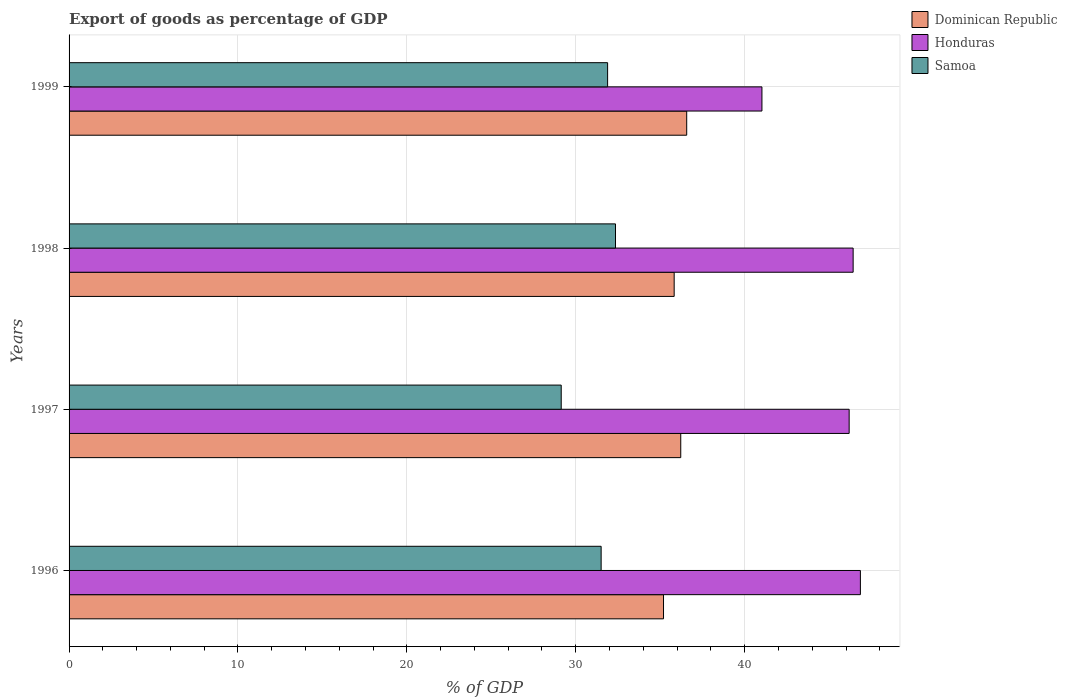How many different coloured bars are there?
Your answer should be compact. 3. How many groups of bars are there?
Offer a very short reply. 4. Are the number of bars on each tick of the Y-axis equal?
Your answer should be compact. Yes. How many bars are there on the 2nd tick from the top?
Give a very brief answer. 3. What is the export of goods as percentage of GDP in Dominican Republic in 1998?
Make the answer very short. 35.83. Across all years, what is the maximum export of goods as percentage of GDP in Dominican Republic?
Offer a terse response. 36.57. Across all years, what is the minimum export of goods as percentage of GDP in Samoa?
Ensure brevity in your answer.  29.14. In which year was the export of goods as percentage of GDP in Dominican Republic maximum?
Offer a very short reply. 1999. What is the total export of goods as percentage of GDP in Honduras in the graph?
Ensure brevity in your answer.  180.48. What is the difference between the export of goods as percentage of GDP in Honduras in 1997 and that in 1998?
Offer a terse response. -0.24. What is the difference between the export of goods as percentage of GDP in Samoa in 1997 and the export of goods as percentage of GDP in Honduras in 1999?
Provide a short and direct response. -11.88. What is the average export of goods as percentage of GDP in Dominican Republic per year?
Offer a very short reply. 35.95. In the year 1997, what is the difference between the export of goods as percentage of GDP in Samoa and export of goods as percentage of GDP in Honduras?
Offer a very short reply. -17.05. What is the ratio of the export of goods as percentage of GDP in Honduras in 1997 to that in 1999?
Keep it short and to the point. 1.13. Is the difference between the export of goods as percentage of GDP in Samoa in 1998 and 1999 greater than the difference between the export of goods as percentage of GDP in Honduras in 1998 and 1999?
Your answer should be very brief. No. What is the difference between the highest and the second highest export of goods as percentage of GDP in Samoa?
Offer a terse response. 0.47. What is the difference between the highest and the lowest export of goods as percentage of GDP in Dominican Republic?
Make the answer very short. 1.37. Is the sum of the export of goods as percentage of GDP in Honduras in 1997 and 1999 greater than the maximum export of goods as percentage of GDP in Dominican Republic across all years?
Offer a terse response. Yes. What does the 3rd bar from the top in 1996 represents?
Ensure brevity in your answer.  Dominican Republic. What does the 1st bar from the bottom in 1996 represents?
Your answer should be very brief. Dominican Republic. Are the values on the major ticks of X-axis written in scientific E-notation?
Provide a succinct answer. No. Does the graph contain any zero values?
Give a very brief answer. No. Does the graph contain grids?
Provide a succinct answer. Yes. Where does the legend appear in the graph?
Your answer should be compact. Top right. How are the legend labels stacked?
Offer a very short reply. Vertical. What is the title of the graph?
Provide a short and direct response. Export of goods as percentage of GDP. Does "Eritrea" appear as one of the legend labels in the graph?
Offer a very short reply. No. What is the label or title of the X-axis?
Ensure brevity in your answer.  % of GDP. What is the % of GDP in Dominican Republic in 1996?
Give a very brief answer. 35.2. What is the % of GDP in Honduras in 1996?
Your response must be concise. 46.85. What is the % of GDP of Samoa in 1996?
Keep it short and to the point. 31.5. What is the % of GDP of Dominican Republic in 1997?
Keep it short and to the point. 36.22. What is the % of GDP of Honduras in 1997?
Your answer should be very brief. 46.19. What is the % of GDP of Samoa in 1997?
Your answer should be compact. 29.14. What is the % of GDP in Dominican Republic in 1998?
Make the answer very short. 35.83. What is the % of GDP in Honduras in 1998?
Give a very brief answer. 46.42. What is the % of GDP in Samoa in 1998?
Ensure brevity in your answer.  32.35. What is the % of GDP of Dominican Republic in 1999?
Keep it short and to the point. 36.57. What is the % of GDP in Honduras in 1999?
Your answer should be compact. 41.02. What is the % of GDP of Samoa in 1999?
Provide a succinct answer. 31.89. Across all years, what is the maximum % of GDP of Dominican Republic?
Offer a very short reply. 36.57. Across all years, what is the maximum % of GDP of Honduras?
Make the answer very short. 46.85. Across all years, what is the maximum % of GDP of Samoa?
Your response must be concise. 32.35. Across all years, what is the minimum % of GDP in Dominican Republic?
Give a very brief answer. 35.2. Across all years, what is the minimum % of GDP in Honduras?
Provide a short and direct response. 41.02. Across all years, what is the minimum % of GDP of Samoa?
Make the answer very short. 29.14. What is the total % of GDP in Dominican Republic in the graph?
Your answer should be compact. 143.81. What is the total % of GDP in Honduras in the graph?
Keep it short and to the point. 180.48. What is the total % of GDP of Samoa in the graph?
Your answer should be compact. 124.88. What is the difference between the % of GDP of Dominican Republic in 1996 and that in 1997?
Ensure brevity in your answer.  -1.02. What is the difference between the % of GDP of Honduras in 1996 and that in 1997?
Offer a very short reply. 0.67. What is the difference between the % of GDP in Samoa in 1996 and that in 1997?
Your answer should be compact. 2.36. What is the difference between the % of GDP of Dominican Republic in 1996 and that in 1998?
Ensure brevity in your answer.  -0.63. What is the difference between the % of GDP of Honduras in 1996 and that in 1998?
Your answer should be compact. 0.43. What is the difference between the % of GDP in Samoa in 1996 and that in 1998?
Provide a short and direct response. -0.85. What is the difference between the % of GDP of Dominican Republic in 1996 and that in 1999?
Your answer should be very brief. -1.37. What is the difference between the % of GDP in Honduras in 1996 and that in 1999?
Offer a terse response. 5.83. What is the difference between the % of GDP of Samoa in 1996 and that in 1999?
Ensure brevity in your answer.  -0.38. What is the difference between the % of GDP in Dominican Republic in 1997 and that in 1998?
Your answer should be very brief. 0.39. What is the difference between the % of GDP of Honduras in 1997 and that in 1998?
Ensure brevity in your answer.  -0.24. What is the difference between the % of GDP in Samoa in 1997 and that in 1998?
Keep it short and to the point. -3.21. What is the difference between the % of GDP of Dominican Republic in 1997 and that in 1999?
Give a very brief answer. -0.35. What is the difference between the % of GDP in Honduras in 1997 and that in 1999?
Your response must be concise. 5.16. What is the difference between the % of GDP in Samoa in 1997 and that in 1999?
Your answer should be very brief. -2.75. What is the difference between the % of GDP of Dominican Republic in 1998 and that in 1999?
Ensure brevity in your answer.  -0.74. What is the difference between the % of GDP of Honduras in 1998 and that in 1999?
Offer a terse response. 5.4. What is the difference between the % of GDP in Samoa in 1998 and that in 1999?
Provide a succinct answer. 0.47. What is the difference between the % of GDP of Dominican Republic in 1996 and the % of GDP of Honduras in 1997?
Provide a short and direct response. -10.99. What is the difference between the % of GDP in Dominican Republic in 1996 and the % of GDP in Samoa in 1997?
Your answer should be very brief. 6.06. What is the difference between the % of GDP in Honduras in 1996 and the % of GDP in Samoa in 1997?
Make the answer very short. 17.71. What is the difference between the % of GDP of Dominican Republic in 1996 and the % of GDP of Honduras in 1998?
Provide a succinct answer. -11.23. What is the difference between the % of GDP in Dominican Republic in 1996 and the % of GDP in Samoa in 1998?
Your response must be concise. 2.84. What is the difference between the % of GDP in Honduras in 1996 and the % of GDP in Samoa in 1998?
Offer a terse response. 14.5. What is the difference between the % of GDP in Dominican Republic in 1996 and the % of GDP in Honduras in 1999?
Provide a succinct answer. -5.83. What is the difference between the % of GDP of Dominican Republic in 1996 and the % of GDP of Samoa in 1999?
Make the answer very short. 3.31. What is the difference between the % of GDP of Honduras in 1996 and the % of GDP of Samoa in 1999?
Provide a short and direct response. 14.97. What is the difference between the % of GDP in Dominican Republic in 1997 and the % of GDP in Honduras in 1998?
Offer a terse response. -10.21. What is the difference between the % of GDP of Dominican Republic in 1997 and the % of GDP of Samoa in 1998?
Give a very brief answer. 3.86. What is the difference between the % of GDP in Honduras in 1997 and the % of GDP in Samoa in 1998?
Keep it short and to the point. 13.83. What is the difference between the % of GDP in Dominican Republic in 1997 and the % of GDP in Honduras in 1999?
Your response must be concise. -4.81. What is the difference between the % of GDP in Dominican Republic in 1997 and the % of GDP in Samoa in 1999?
Your response must be concise. 4.33. What is the difference between the % of GDP in Honduras in 1997 and the % of GDP in Samoa in 1999?
Your response must be concise. 14.3. What is the difference between the % of GDP of Dominican Republic in 1998 and the % of GDP of Honduras in 1999?
Give a very brief answer. -5.2. What is the difference between the % of GDP of Dominican Republic in 1998 and the % of GDP of Samoa in 1999?
Keep it short and to the point. 3.94. What is the difference between the % of GDP of Honduras in 1998 and the % of GDP of Samoa in 1999?
Keep it short and to the point. 14.54. What is the average % of GDP in Dominican Republic per year?
Your response must be concise. 35.95. What is the average % of GDP in Honduras per year?
Offer a terse response. 45.12. What is the average % of GDP in Samoa per year?
Your response must be concise. 31.22. In the year 1996, what is the difference between the % of GDP in Dominican Republic and % of GDP in Honduras?
Your answer should be very brief. -11.66. In the year 1996, what is the difference between the % of GDP of Dominican Republic and % of GDP of Samoa?
Your answer should be very brief. 3.69. In the year 1996, what is the difference between the % of GDP of Honduras and % of GDP of Samoa?
Your response must be concise. 15.35. In the year 1997, what is the difference between the % of GDP of Dominican Republic and % of GDP of Honduras?
Give a very brief answer. -9.97. In the year 1997, what is the difference between the % of GDP in Dominican Republic and % of GDP in Samoa?
Ensure brevity in your answer.  7.08. In the year 1997, what is the difference between the % of GDP in Honduras and % of GDP in Samoa?
Make the answer very short. 17.05. In the year 1998, what is the difference between the % of GDP in Dominican Republic and % of GDP in Honduras?
Provide a short and direct response. -10.6. In the year 1998, what is the difference between the % of GDP of Dominican Republic and % of GDP of Samoa?
Offer a terse response. 3.47. In the year 1998, what is the difference between the % of GDP in Honduras and % of GDP in Samoa?
Provide a succinct answer. 14.07. In the year 1999, what is the difference between the % of GDP in Dominican Republic and % of GDP in Honduras?
Keep it short and to the point. -4.45. In the year 1999, what is the difference between the % of GDP in Dominican Republic and % of GDP in Samoa?
Make the answer very short. 4.68. In the year 1999, what is the difference between the % of GDP in Honduras and % of GDP in Samoa?
Offer a very short reply. 9.14. What is the ratio of the % of GDP of Dominican Republic in 1996 to that in 1997?
Ensure brevity in your answer.  0.97. What is the ratio of the % of GDP in Honduras in 1996 to that in 1997?
Offer a very short reply. 1.01. What is the ratio of the % of GDP in Samoa in 1996 to that in 1997?
Make the answer very short. 1.08. What is the ratio of the % of GDP of Dominican Republic in 1996 to that in 1998?
Keep it short and to the point. 0.98. What is the ratio of the % of GDP of Honduras in 1996 to that in 1998?
Keep it short and to the point. 1.01. What is the ratio of the % of GDP of Samoa in 1996 to that in 1998?
Offer a very short reply. 0.97. What is the ratio of the % of GDP in Dominican Republic in 1996 to that in 1999?
Your answer should be compact. 0.96. What is the ratio of the % of GDP in Honduras in 1996 to that in 1999?
Your answer should be very brief. 1.14. What is the ratio of the % of GDP in Samoa in 1996 to that in 1999?
Offer a terse response. 0.99. What is the ratio of the % of GDP of Dominican Republic in 1997 to that in 1998?
Provide a short and direct response. 1.01. What is the ratio of the % of GDP in Samoa in 1997 to that in 1998?
Provide a succinct answer. 0.9. What is the ratio of the % of GDP in Honduras in 1997 to that in 1999?
Your response must be concise. 1.13. What is the ratio of the % of GDP of Samoa in 1997 to that in 1999?
Your response must be concise. 0.91. What is the ratio of the % of GDP in Dominican Republic in 1998 to that in 1999?
Ensure brevity in your answer.  0.98. What is the ratio of the % of GDP in Honduras in 1998 to that in 1999?
Make the answer very short. 1.13. What is the ratio of the % of GDP of Samoa in 1998 to that in 1999?
Offer a terse response. 1.01. What is the difference between the highest and the second highest % of GDP of Dominican Republic?
Provide a short and direct response. 0.35. What is the difference between the highest and the second highest % of GDP of Honduras?
Offer a terse response. 0.43. What is the difference between the highest and the second highest % of GDP in Samoa?
Keep it short and to the point. 0.47. What is the difference between the highest and the lowest % of GDP in Dominican Republic?
Give a very brief answer. 1.37. What is the difference between the highest and the lowest % of GDP in Honduras?
Your answer should be compact. 5.83. What is the difference between the highest and the lowest % of GDP in Samoa?
Provide a short and direct response. 3.21. 